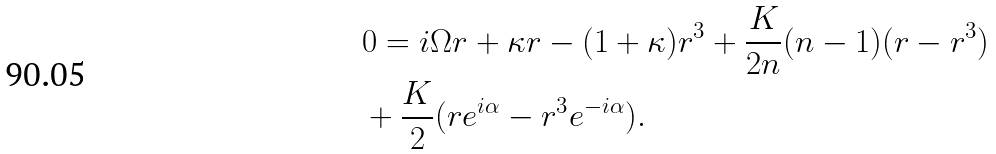Convert formula to latex. <formula><loc_0><loc_0><loc_500><loc_500>& 0 = i \Omega r + \kappa r - ( 1 + \kappa ) r ^ { 3 } + \frac { K } { 2 n } ( n - 1 ) ( r - r ^ { 3 } ) \\ & + \frac { K } { 2 } ( r e ^ { i \alpha } - r ^ { 3 } e ^ { - i \alpha } ) .</formula> 